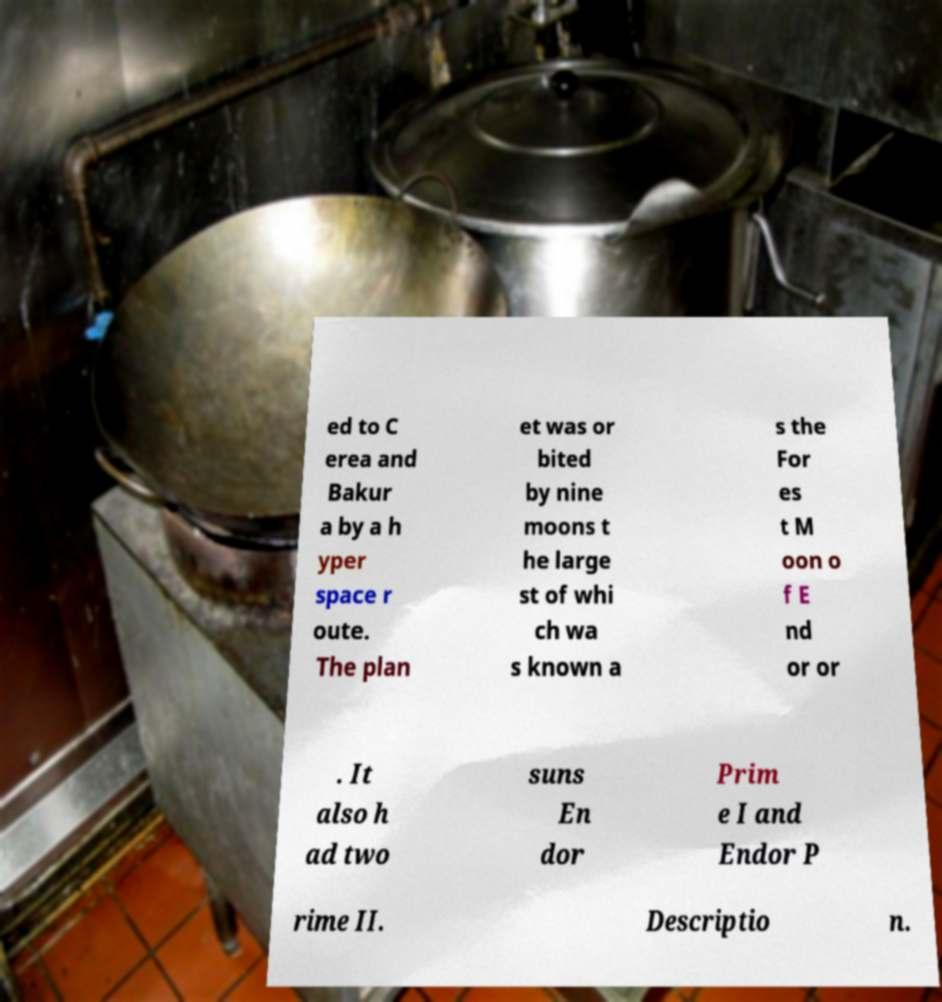Can you read and provide the text displayed in the image?This photo seems to have some interesting text. Can you extract and type it out for me? ed to C erea and Bakur a by a h yper space r oute. The plan et was or bited by nine moons t he large st of whi ch wa s known a s the For es t M oon o f E nd or or . It also h ad two suns En dor Prim e I and Endor P rime II. Descriptio n. 